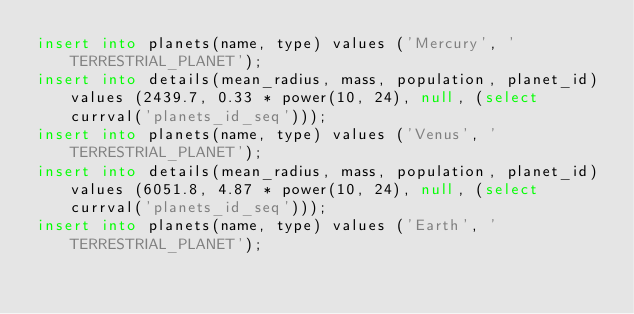<code> <loc_0><loc_0><loc_500><loc_500><_SQL_>insert into planets(name, type) values ('Mercury', 'TERRESTRIAL_PLANET');
insert into details(mean_radius, mass, population, planet_id) values (2439.7, 0.33 * power(10, 24), null, (select currval('planets_id_seq')));
insert into planets(name, type) values ('Venus', 'TERRESTRIAL_PLANET');
insert into details(mean_radius, mass, population, planet_id) values (6051.8, 4.87 * power(10, 24), null, (select currval('planets_id_seq')));
insert into planets(name, type) values ('Earth', 'TERRESTRIAL_PLANET');</code> 